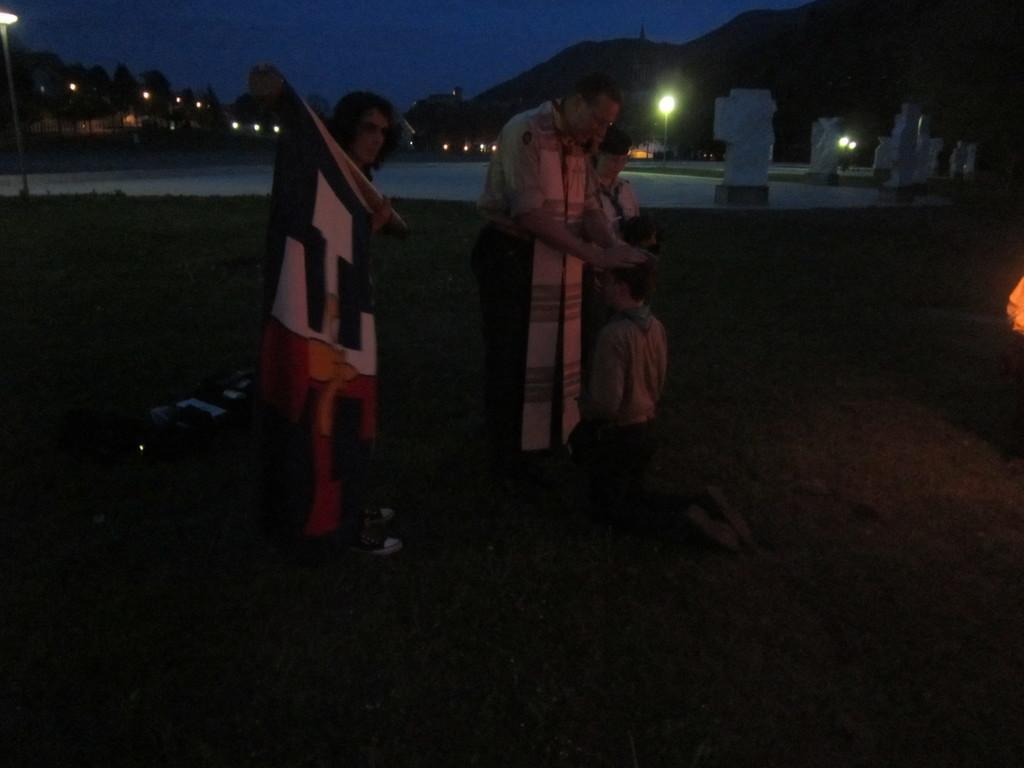How would you summarize this image in a sentence or two? In this picture, in the middle, we can see two person are standing. On the left side, we can also see a person standing. In the background there are some trees, mountains. On the top, we can see a sky. 